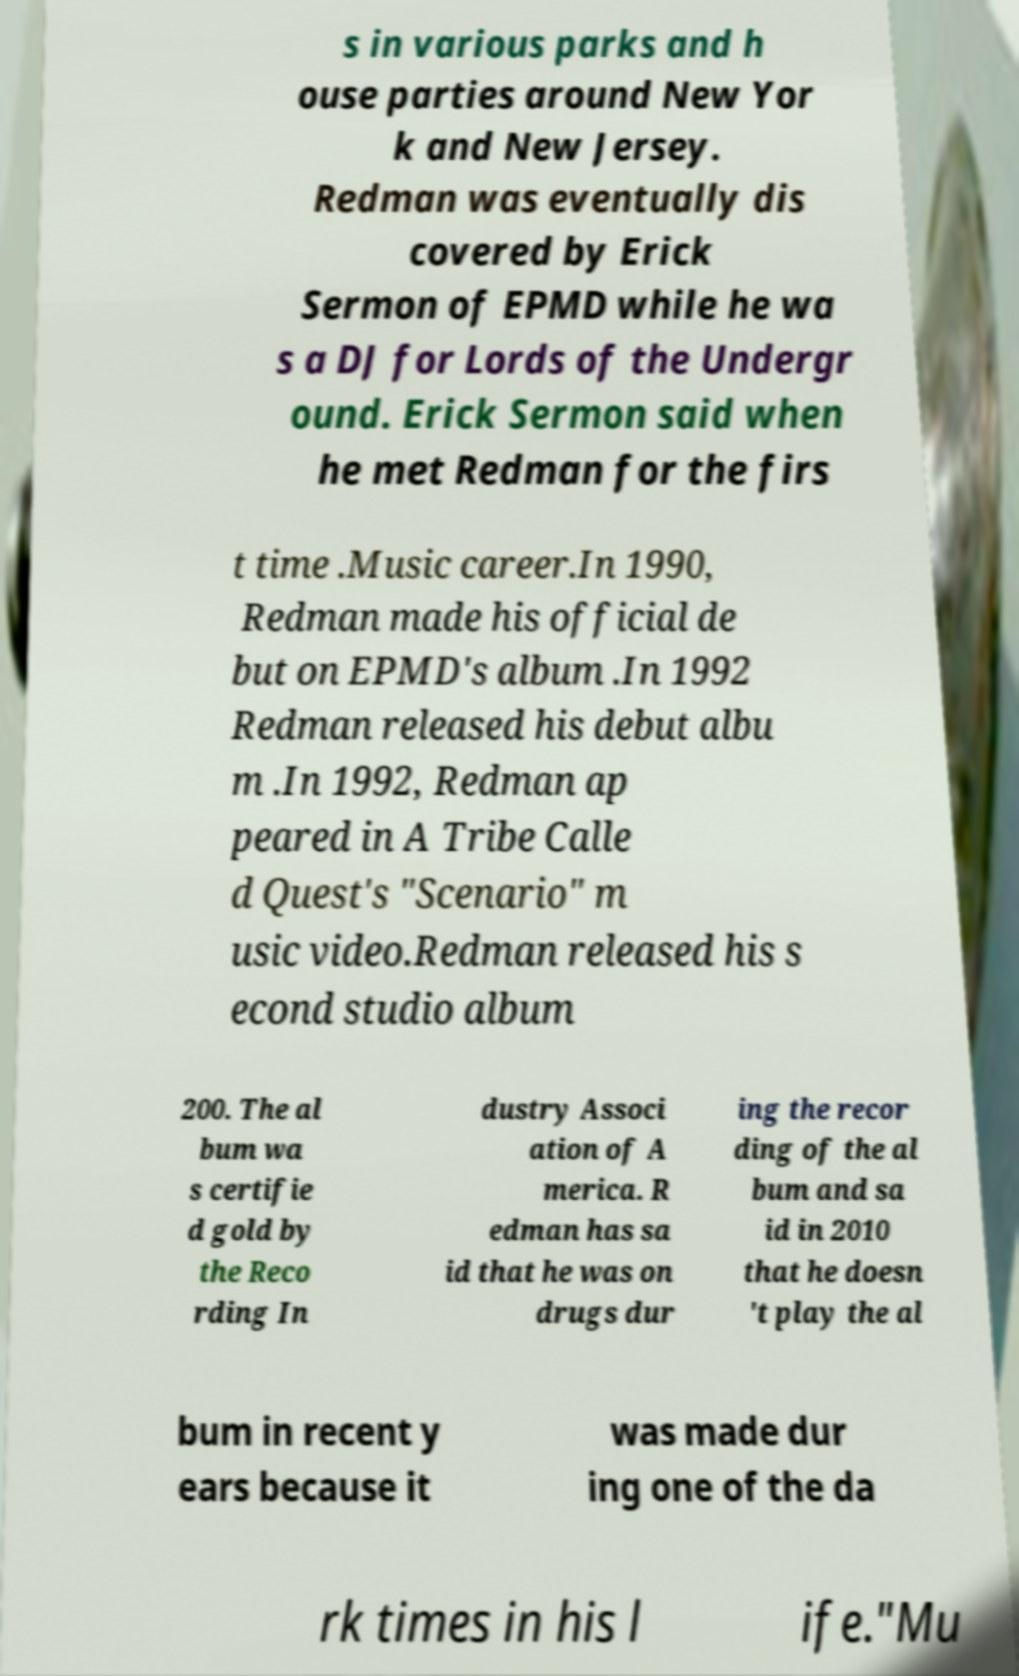I need the written content from this picture converted into text. Can you do that? s in various parks and h ouse parties around New Yor k and New Jersey. Redman was eventually dis covered by Erick Sermon of EPMD while he wa s a DJ for Lords of the Undergr ound. Erick Sermon said when he met Redman for the firs t time .Music career.In 1990, Redman made his official de but on EPMD's album .In 1992 Redman released his debut albu m .In 1992, Redman ap peared in A Tribe Calle d Quest's "Scenario" m usic video.Redman released his s econd studio album 200. The al bum wa s certifie d gold by the Reco rding In dustry Associ ation of A merica. R edman has sa id that he was on drugs dur ing the recor ding of the al bum and sa id in 2010 that he doesn 't play the al bum in recent y ears because it was made dur ing one of the da rk times in his l ife."Mu 